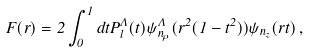<formula> <loc_0><loc_0><loc_500><loc_500>F ( r ) = 2 \int _ { 0 } ^ { 1 } d t P ^ { \Lambda } _ { l } ( t ) \psi ^ { \Lambda } _ { n _ { \rho } } ( r ^ { 2 } ( 1 - t ^ { 2 } ) ) \psi _ { n _ { z } } ( r t ) \, ,</formula> 